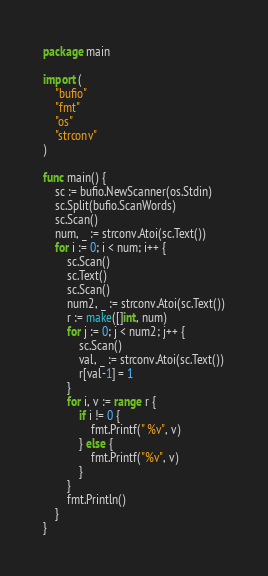Convert code to text. <code><loc_0><loc_0><loc_500><loc_500><_Go_>package main

import (
	"bufio"
	"fmt"
	"os"
	"strconv"
)

func main() {
	sc := bufio.NewScanner(os.Stdin)
	sc.Split(bufio.ScanWords)
	sc.Scan()
	num, _ := strconv.Atoi(sc.Text())
	for i := 0; i < num; i++ {
		sc.Scan()
		sc.Text()
		sc.Scan()
		num2, _ := strconv.Atoi(sc.Text())
		r := make([]int, num)
		for j := 0; j < num2; j++ {
			sc.Scan()
			val, _ := strconv.Atoi(sc.Text())
			r[val-1] = 1
		}
		for i, v := range r {
			if i != 0 {
				fmt.Printf(" %v", v)
			} else {
				fmt.Printf("%v", v)
			}
		}
		fmt.Println()
	}
}

</code> 